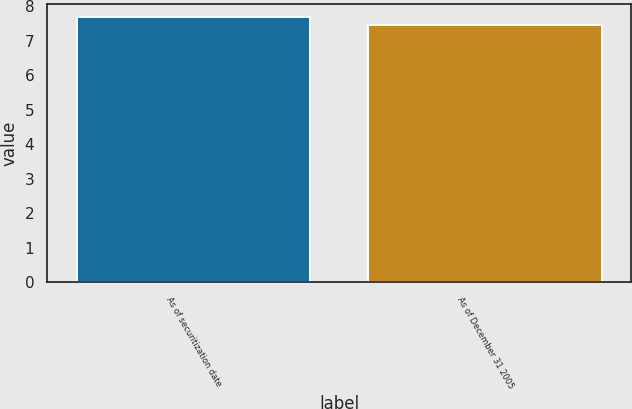Convert chart. <chart><loc_0><loc_0><loc_500><loc_500><bar_chart><fcel>As of securitization date<fcel>As of December 31 2005<nl><fcel>7.68<fcel>7.46<nl></chart> 